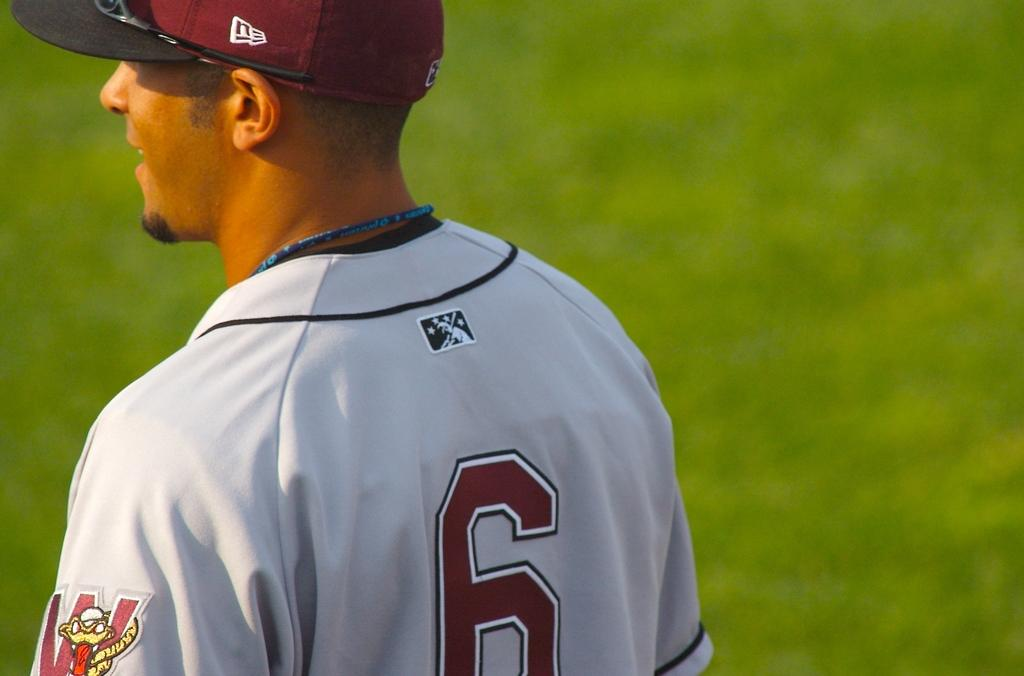<image>
Render a clear and concise summary of the photo. The player in white wears the number 6 on his back. 